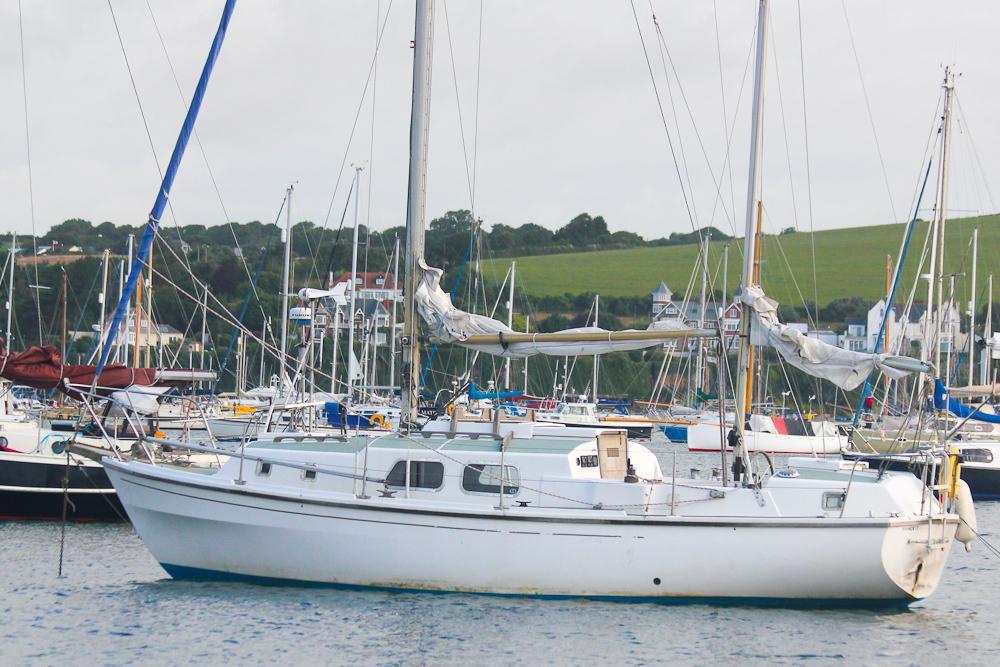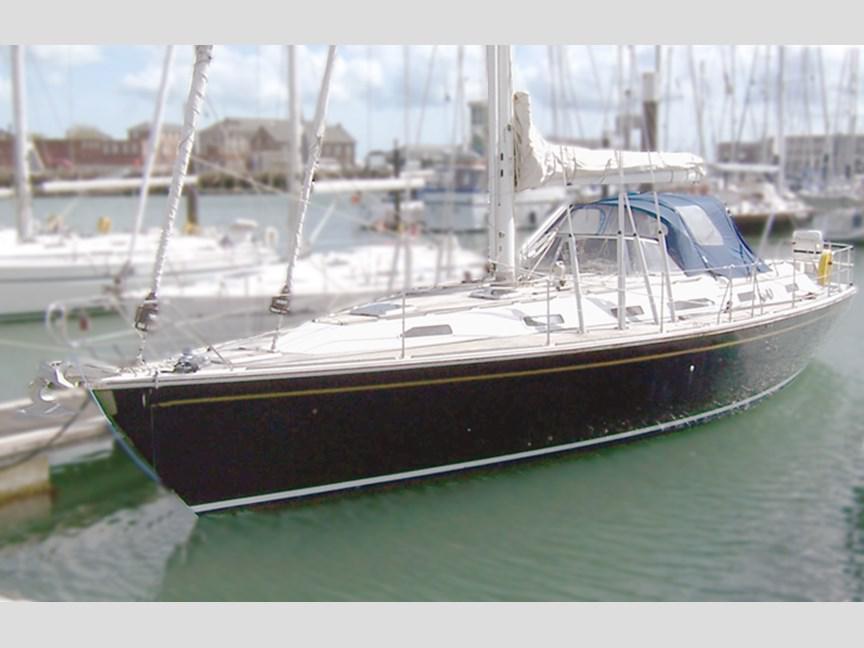The first image is the image on the left, the second image is the image on the right. Analyze the images presented: Is the assertion "There are at least two blue sails." valid? Answer yes or no. No. 